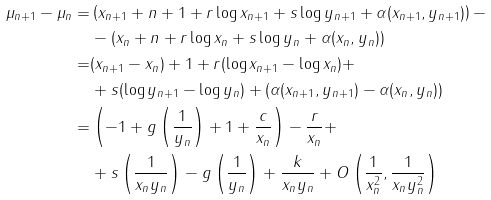Convert formula to latex. <formula><loc_0><loc_0><loc_500><loc_500>\mu _ { n + 1 } - \mu _ { n } = & \left ( x _ { n + 1 } + n + 1 + r \log x _ { n + 1 } + s \log y _ { n + 1 } + \alpha ( x _ { n + 1 } , y _ { n + 1 } ) \right ) - \\ & - ( x _ { n } + n + r \log x _ { n } + s \log y _ { n } + \alpha ( x _ { n } , y _ { n } ) ) \\ = & ( x _ { n + 1 } - x _ { n } ) + 1 + r ( \log x _ { n + 1 } - \log x _ { n } ) + \\ & + s ( \log y _ { n + 1 } - \log y _ { n } ) + ( \alpha ( x _ { n + 1 } , y _ { n + 1 } ) - \alpha ( x _ { n } , y _ { n } ) ) \\ = & \left ( - 1 + g \left ( \frac { 1 } { y _ { n } } \right ) + 1 + \frac { c } { x _ { n } } \right ) - \frac { r } { x _ { n } } + \\ & + s \left ( \frac { 1 } { x _ { n } y _ { n } } \right ) - g \left ( \frac { 1 } { y _ { n } } \right ) + \frac { k } { x _ { n } y _ { n } } + O \left ( \frac { 1 } { x _ { n } ^ { 2 } } , \frac { 1 } { x _ { n } y _ { n } ^ { 2 } } \right )</formula> 